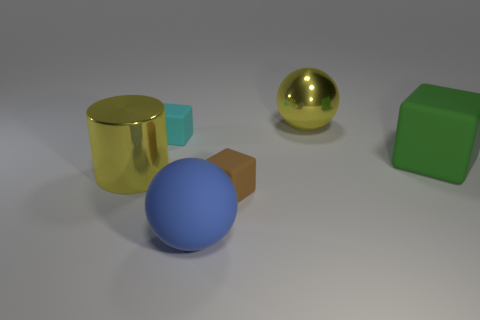How many other objects are there of the same material as the big green block?
Ensure brevity in your answer.  3. There is a matte object that is both behind the blue rubber sphere and left of the brown object; what shape is it?
Your answer should be compact. Cube. Do the ball behind the big blue thing and the metallic thing that is in front of the cyan cube have the same size?
Give a very brief answer. Yes. There is a big object that is made of the same material as the big cylinder; what shape is it?
Make the answer very short. Sphere. Is there anything else that has the same shape as the small cyan rubber thing?
Provide a succinct answer. Yes. What is the color of the large matte object right of the yellow object that is right of the large yellow object that is to the left of the small brown thing?
Your response must be concise. Green. Are there fewer large metallic cylinders to the right of the large green cube than big metallic cylinders behind the big yellow metal cylinder?
Ensure brevity in your answer.  No. Is the large green thing the same shape as the big blue matte object?
Provide a succinct answer. No. What number of brown blocks have the same size as the cyan rubber thing?
Provide a short and direct response. 1. Is the number of blocks left of the big blue ball less than the number of small purple things?
Provide a succinct answer. No. 